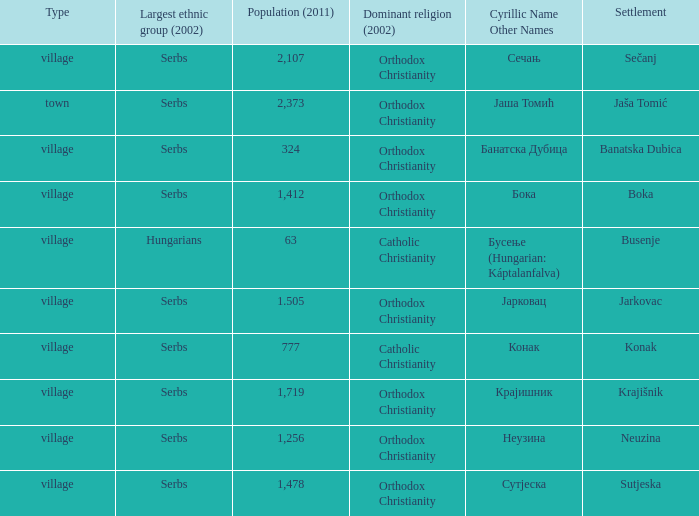Can you give me this table as a dict? {'header': ['Type', 'Largest ethnic group (2002)', 'Population (2011)', 'Dominant religion (2002)', 'Cyrillic Name Other Names', 'Settlement'], 'rows': [['village', 'Serbs', '2,107', 'Orthodox Christianity', 'Сечањ', 'Sečanj'], ['town', 'Serbs', '2,373', 'Orthodox Christianity', 'Јаша Томић', 'Jaša Tomić'], ['village', 'Serbs', '324', 'Orthodox Christianity', 'Банатска Дубица', 'Banatska Dubica'], ['village', 'Serbs', '1,412', 'Orthodox Christianity', 'Бока', 'Boka'], ['village', 'Hungarians', '63', 'Catholic Christianity', 'Бусење (Hungarian: Káptalanfalva)', 'Busenje'], ['village', 'Serbs', '1.505', 'Orthodox Christianity', 'Јарковац', 'Jarkovac'], ['village', 'Serbs', '777', 'Catholic Christianity', 'Конак', 'Konak'], ['village', 'Serbs', '1,719', 'Orthodox Christianity', 'Крајишник', 'Krajišnik'], ['village', 'Serbs', '1,256', 'Orthodox Christianity', 'Неузина', 'Neuzina'], ['village', 'Serbs', '1,478', 'Orthodox Christianity', 'Сутјеска', 'Sutjeska']]} What town has the population of 777? Конак. 